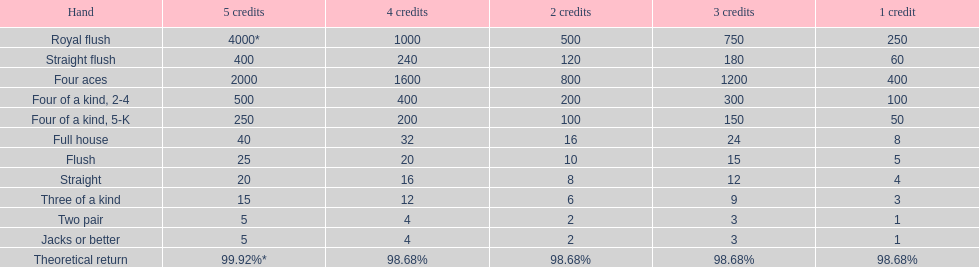After winning on four credits with a full house, what is your payout? 32. 